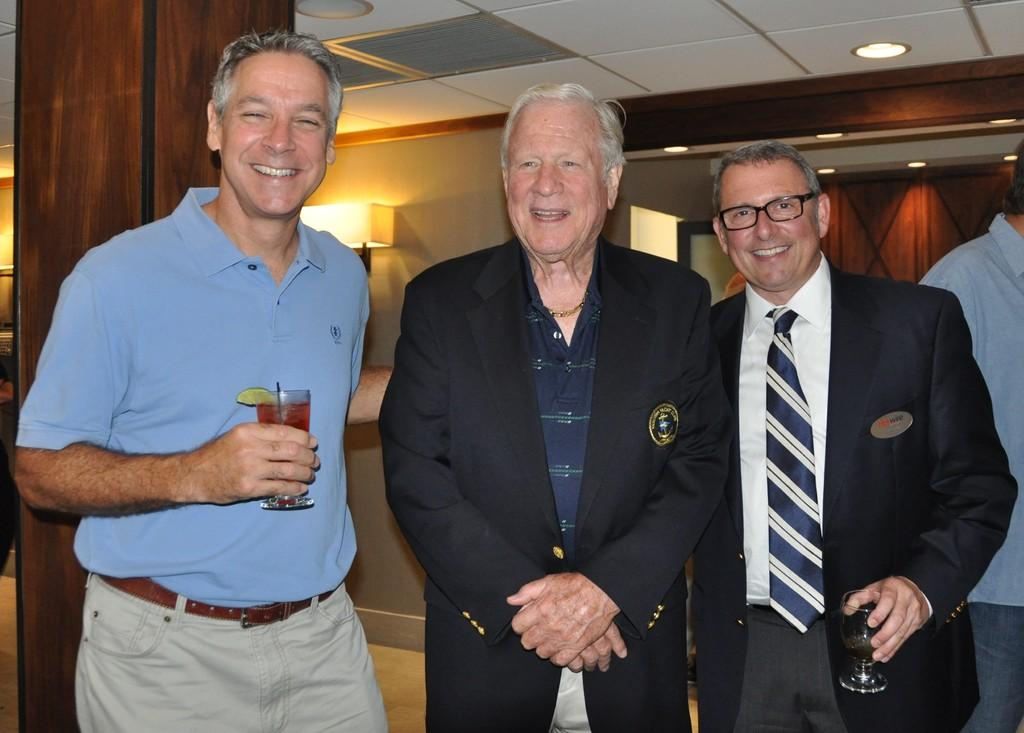How many people are in the foreground of the image? There are three men in the foreground of the image. What are the men doing in the image? The men are standing and posing for a photo. What can be seen in the background of the image? There is a wall and a light in the background of the image. What type of advertisement can be seen on the wall in the image? There is no advertisement present on the wall in the image; it is a plain wall. 